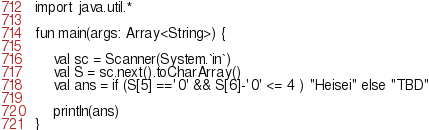<code> <loc_0><loc_0><loc_500><loc_500><_Kotlin_>import java.util.*

fun main(args: Array<String>) {

    val sc = Scanner(System.`in`)
    val S = sc.next().toCharArray()
    val ans = if (S[5] =='0' && S[6]-'0' <= 4 ) "Heisei" else "TBD"

    println(ans)
}</code> 